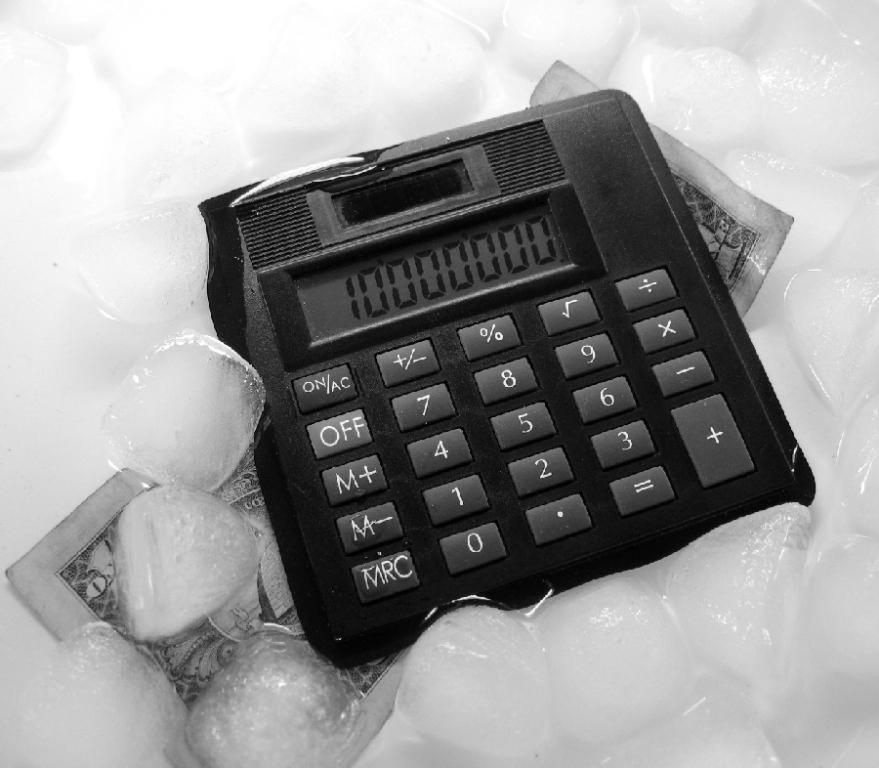<image>
Provide a brief description of the given image. A calculator surrounded by ice in a sink showcasing the number 10000000. 